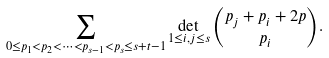<formula> <loc_0><loc_0><loc_500><loc_500>\sum _ { 0 \leq p _ { 1 } < p _ { 2 } < \dots < p _ { s - 1 } < p _ { s } \leq s + t - 1 } \det _ { 1 \leq i , j \leq s } \binom { p _ { j } + p _ { i } + 2 p } { p _ { i } } .</formula> 